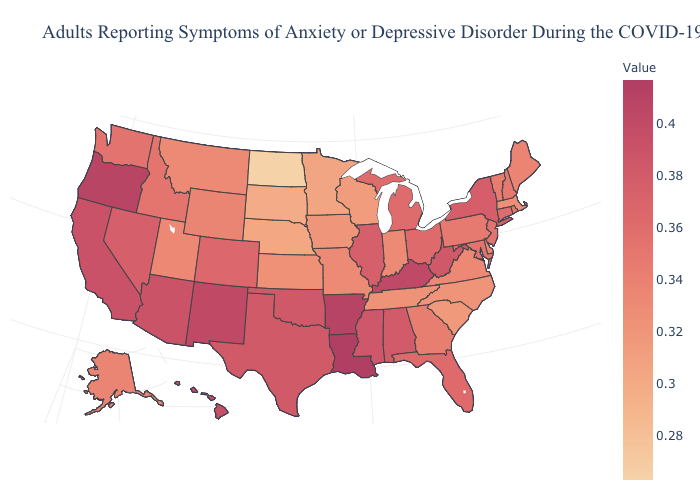Which states have the lowest value in the USA?
Concise answer only. North Dakota. Does Louisiana have the lowest value in the USA?
Short answer required. No. Among the states that border Minnesota , does South Dakota have the lowest value?
Keep it brief. No. 